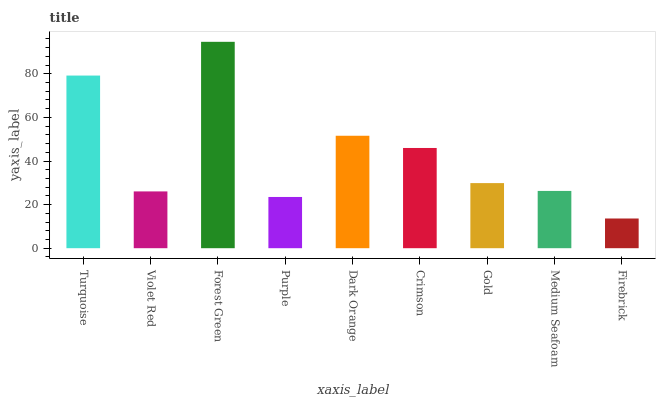Is Firebrick the minimum?
Answer yes or no. Yes. Is Forest Green the maximum?
Answer yes or no. Yes. Is Violet Red the minimum?
Answer yes or no. No. Is Violet Red the maximum?
Answer yes or no. No. Is Turquoise greater than Violet Red?
Answer yes or no. Yes. Is Violet Red less than Turquoise?
Answer yes or no. Yes. Is Violet Red greater than Turquoise?
Answer yes or no. No. Is Turquoise less than Violet Red?
Answer yes or no. No. Is Gold the high median?
Answer yes or no. Yes. Is Gold the low median?
Answer yes or no. Yes. Is Crimson the high median?
Answer yes or no. No. Is Forest Green the low median?
Answer yes or no. No. 